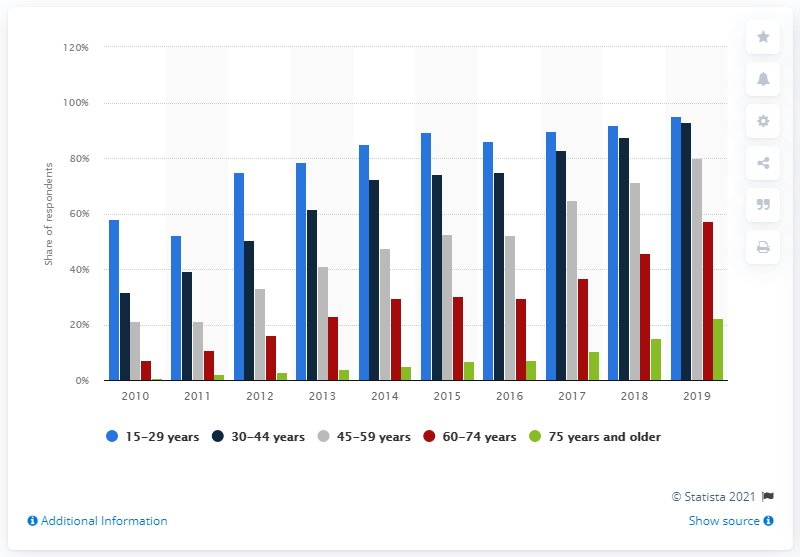Specify some key components in this picture. In the three months preceding this survey, 95.1% of individuals aged 15 to 29 accessed mobile internet. 